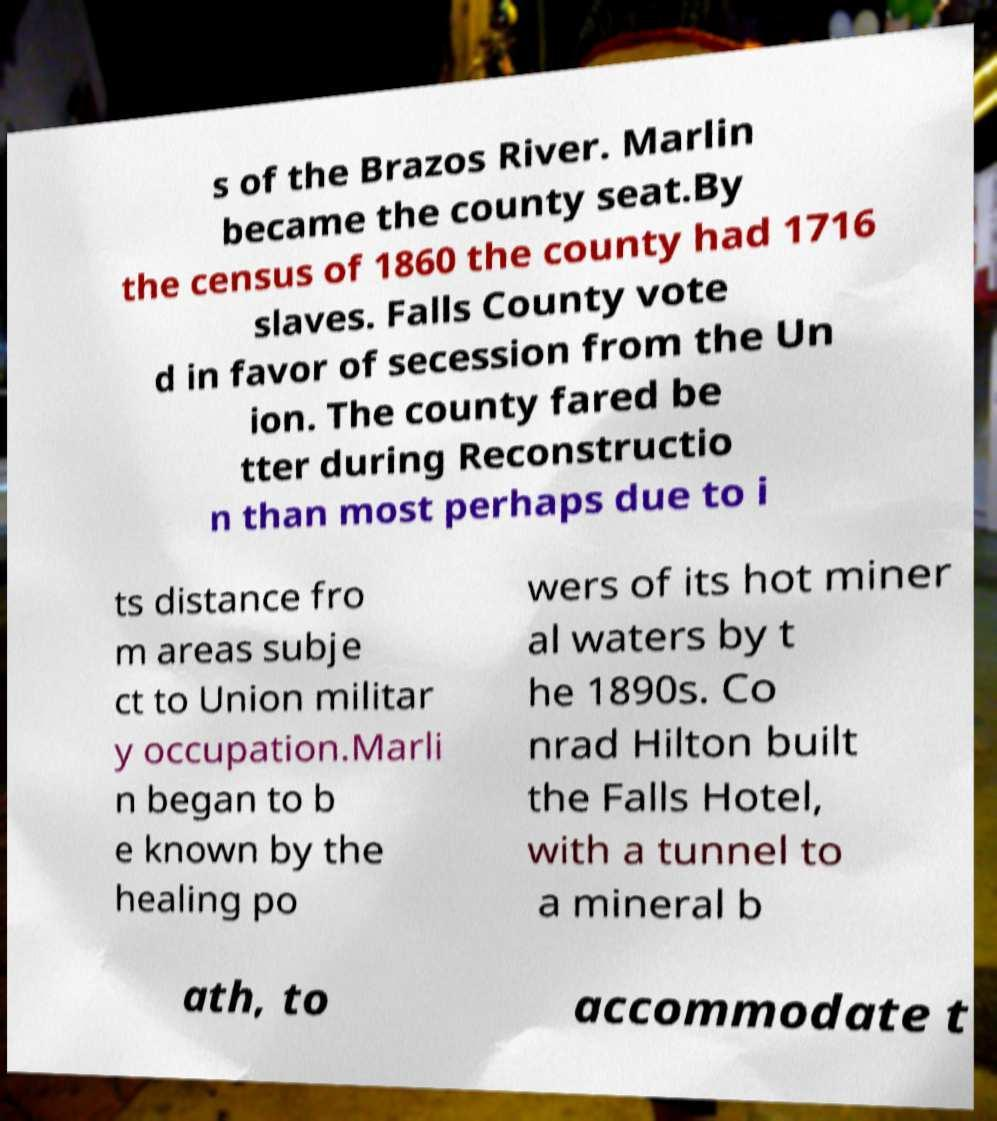Can you read and provide the text displayed in the image?This photo seems to have some interesting text. Can you extract and type it out for me? s of the Brazos River. Marlin became the county seat.By the census of 1860 the county had 1716 slaves. Falls County vote d in favor of secession from the Un ion. The county fared be tter during Reconstructio n than most perhaps due to i ts distance fro m areas subje ct to Union militar y occupation.Marli n began to b e known by the healing po wers of its hot miner al waters by t he 1890s. Co nrad Hilton built the Falls Hotel, with a tunnel to a mineral b ath, to accommodate t 